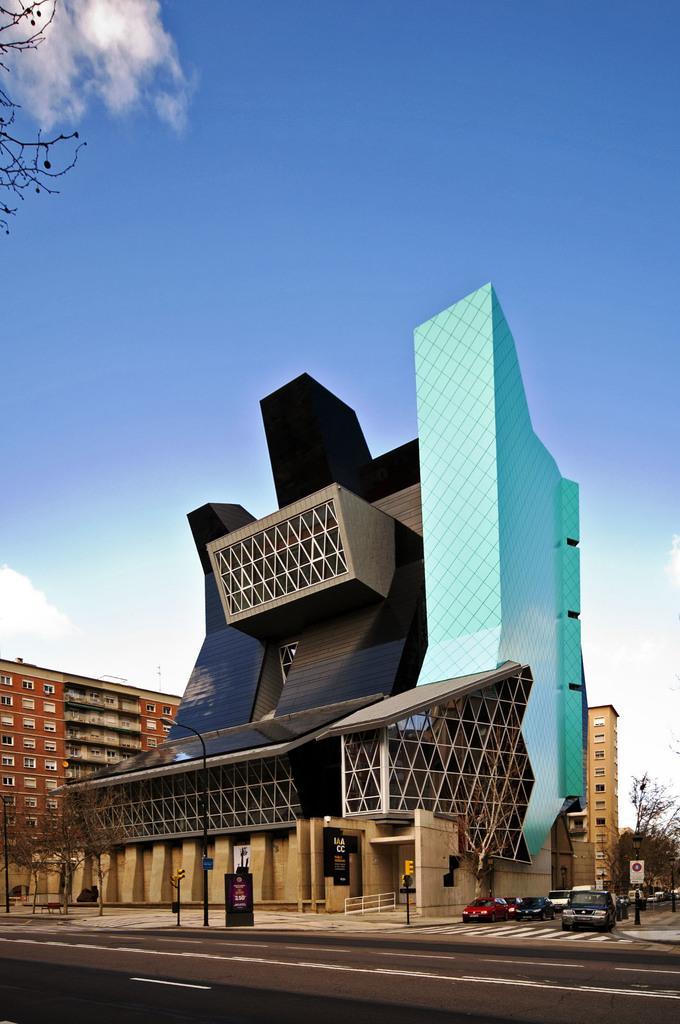How would you summarize this image in a sentence or two? In this image I can see few vehicles, light poles, buildings, trees and the sky is in blue and white color. 